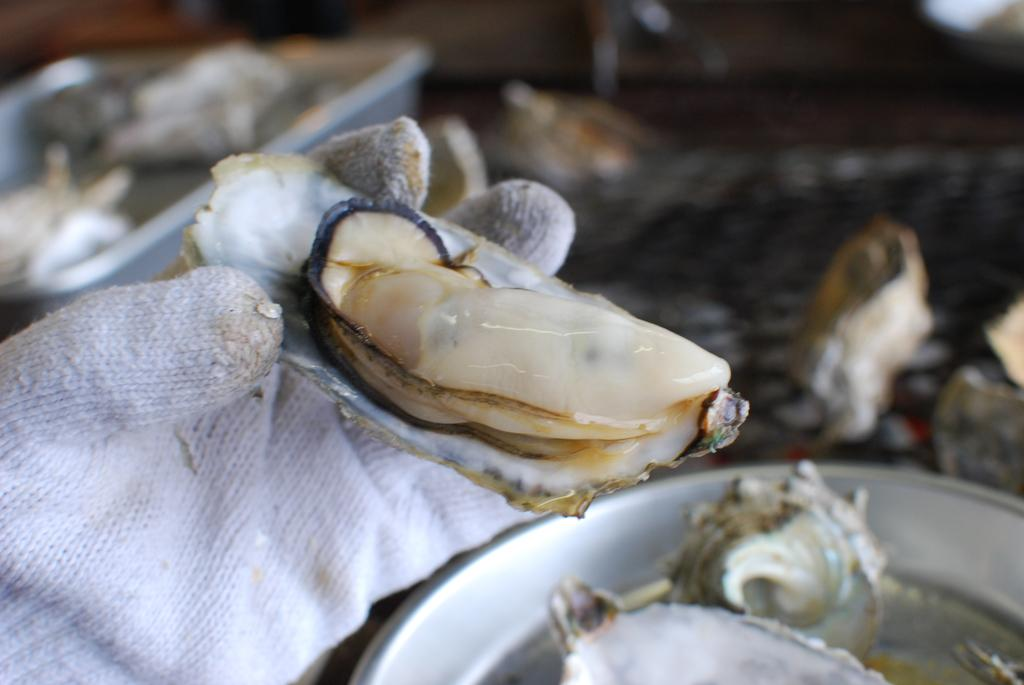What can be seen on the hand in the image? There is a hand with a glove in the image. What is the hand holding? The hand is holding something, but the specific object is not mentioned in the facts. What is on the floor in the image? There are plates on the floor in the image. What is on the plates? There is an unspecified object on the plates. How would you describe the background of the image? The background of the image is blurry. What type of metal can be seen on the planes in the image? There are no planes or metal present in the image. What type of blade is being used by the person in the image? There is no person or blade present in the image. 